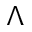<formula> <loc_0><loc_0><loc_500><loc_500>\Lambda</formula> 